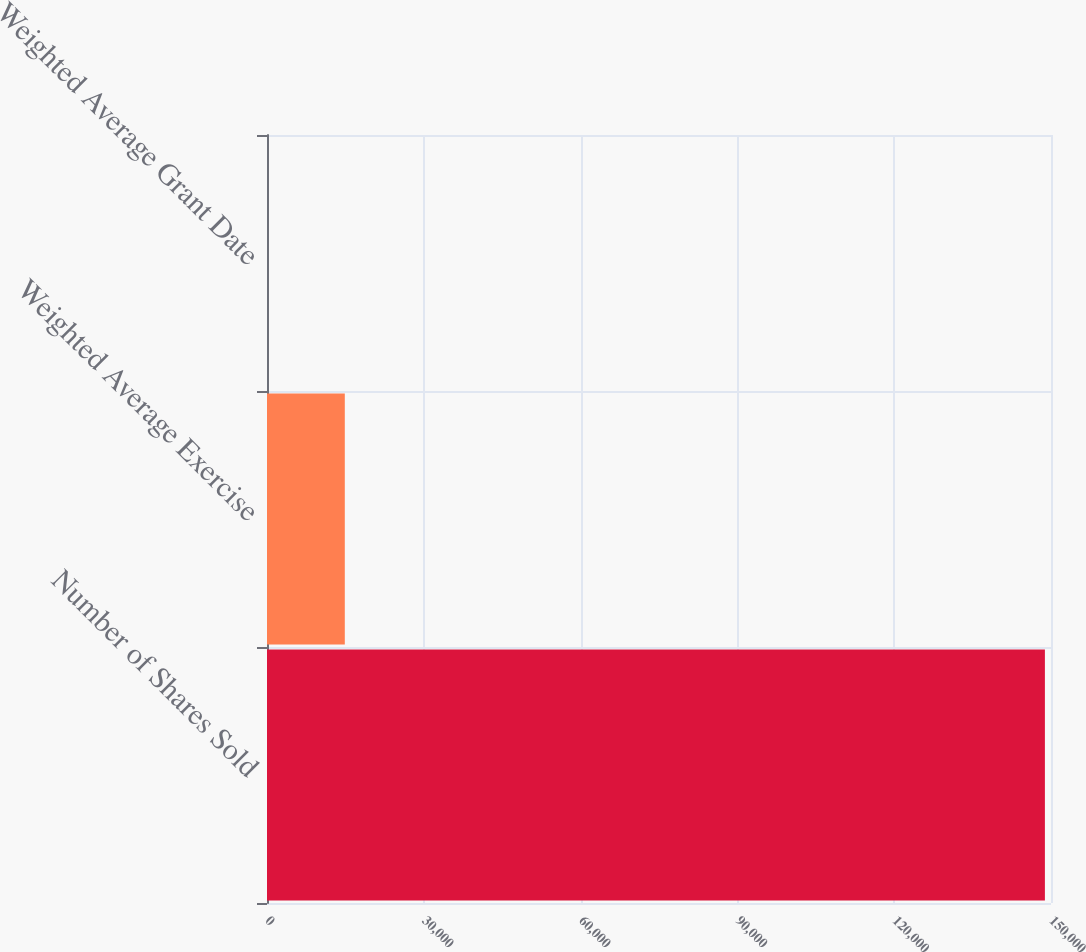Convert chart. <chart><loc_0><loc_0><loc_500><loc_500><bar_chart><fcel>Number of Shares Sold<fcel>Weighted Average Exercise<fcel>Weighted Average Grant Date<nl><fcel>148833<fcel>14886.8<fcel>3.9<nl></chart> 